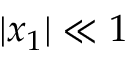<formula> <loc_0><loc_0><loc_500><loc_500>| x _ { 1 } | \ll 1</formula> 